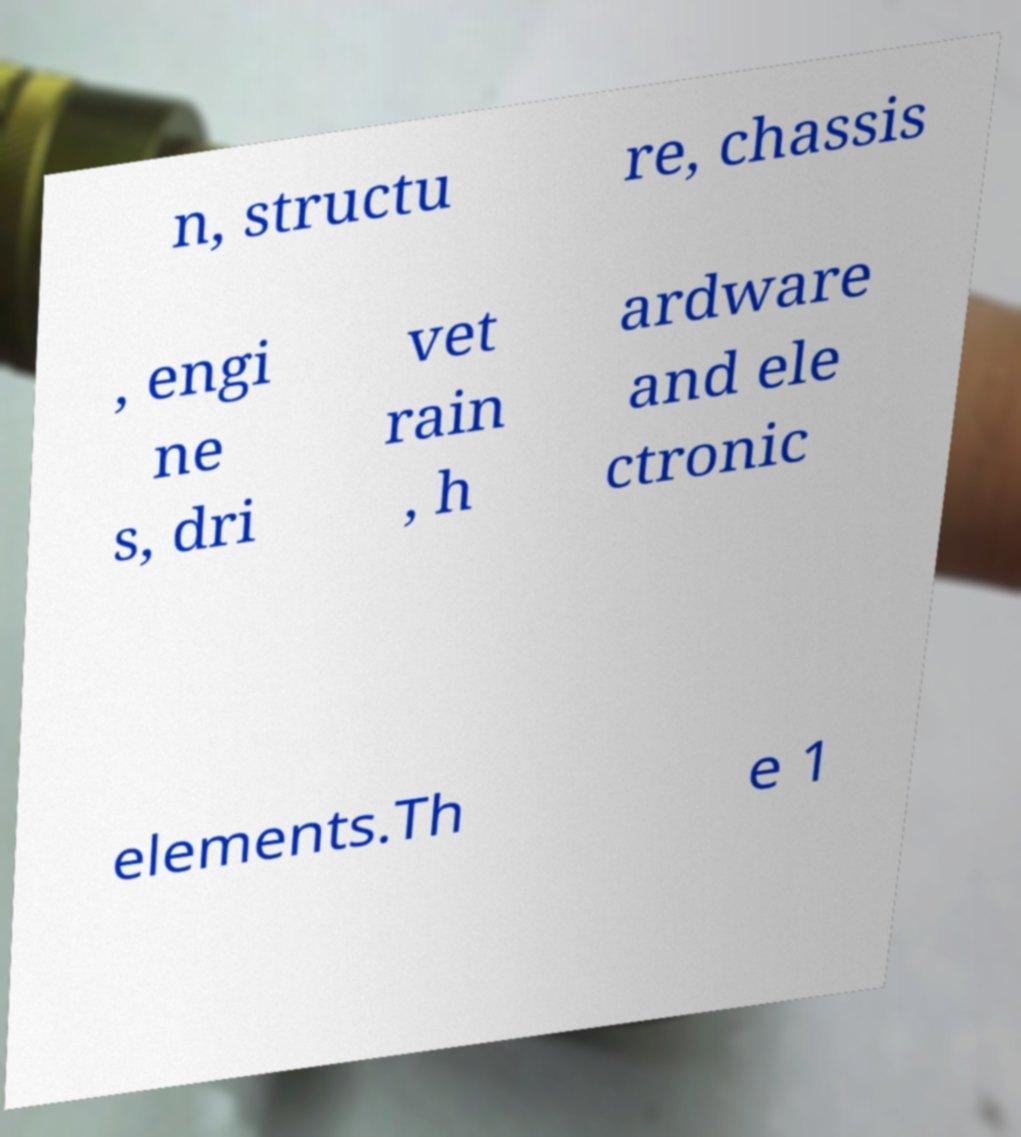There's text embedded in this image that I need extracted. Can you transcribe it verbatim? n, structu re, chassis , engi ne s, dri vet rain , h ardware and ele ctronic elements.Th e 1 